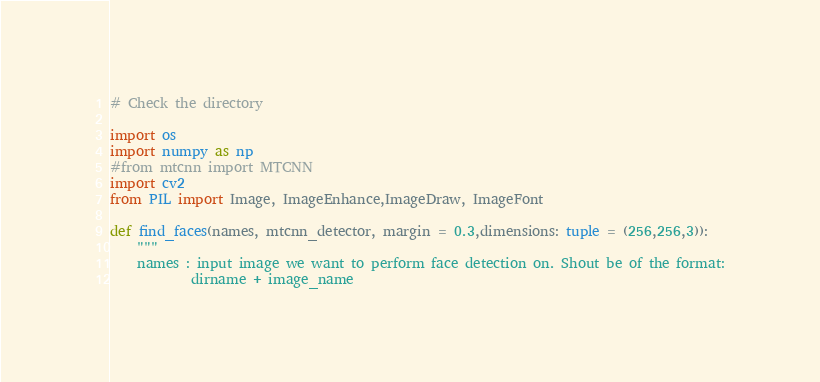<code> <loc_0><loc_0><loc_500><loc_500><_Python_># Check the directory

import os
import numpy as np
#from mtcnn import MTCNN
import cv2
from PIL import Image, ImageEnhance,ImageDraw, ImageFont

def find_faces(names, mtcnn_detector, margin = 0.3,dimensions: tuple = (256,256,3)):
    """
    names : input image we want to perform face detection on. Shout be of the format:
            dirname + image_name
</code> 